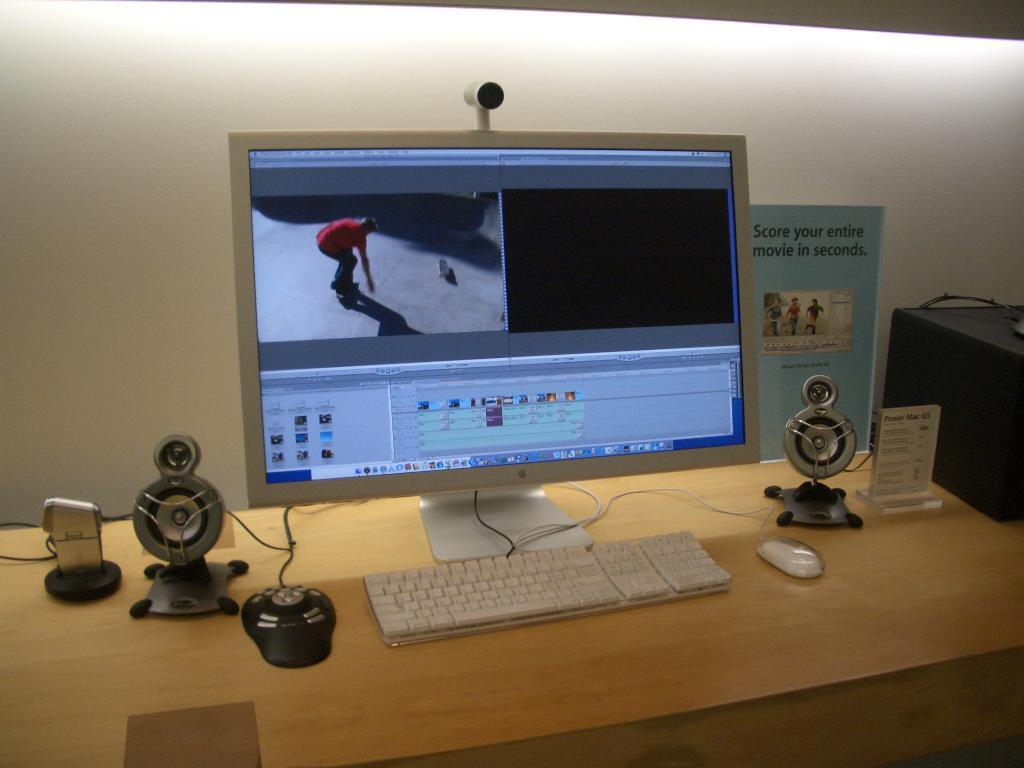<image>
Relay a brief, clear account of the picture shown. A computer is at a table next to a sign that says Score your entire movie in seconds. 